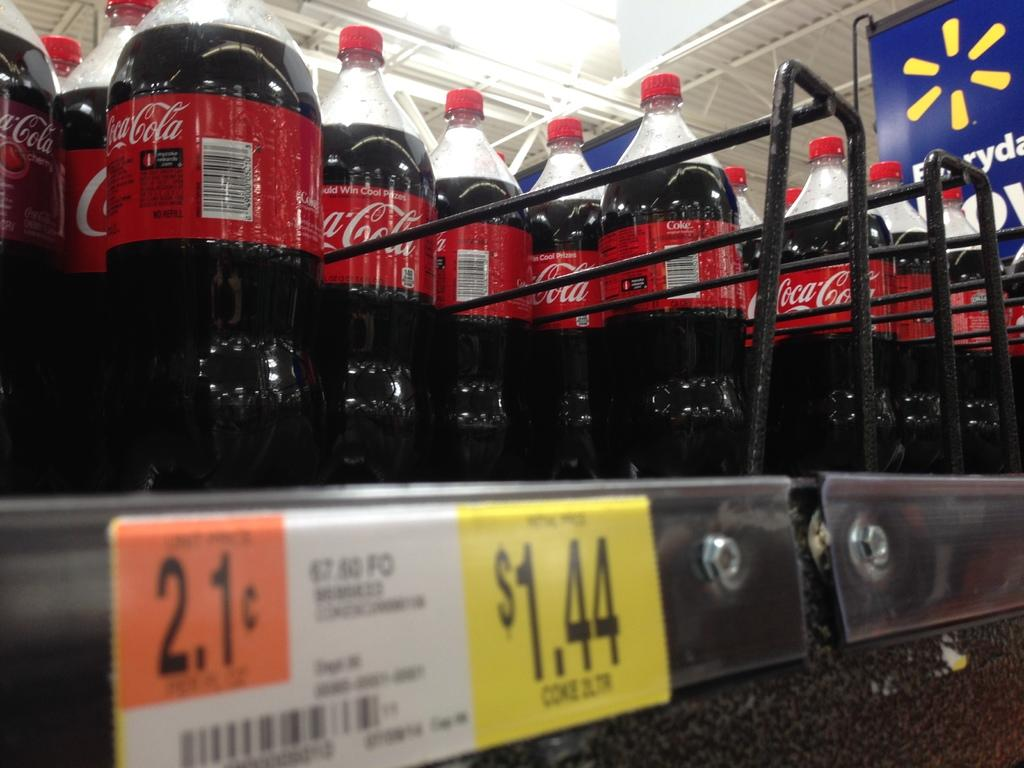What type of product is featured in the image? There are coca cola bottles in the image. How are the bottles arranged in the image? The bottles are in racks. Is there any pricing information visible in the image? Yes, there is a price tag on the left side of the image. What can be seen above the bottles in the image? There are lights and a ceiling visible at the top of the image. What is on the right side of the image? There is a banner on the right side of the image. Can you tell me how many times the person in the image sneezes? There is no person present in the image, so it is not possible to determine how many times they sneeze. 